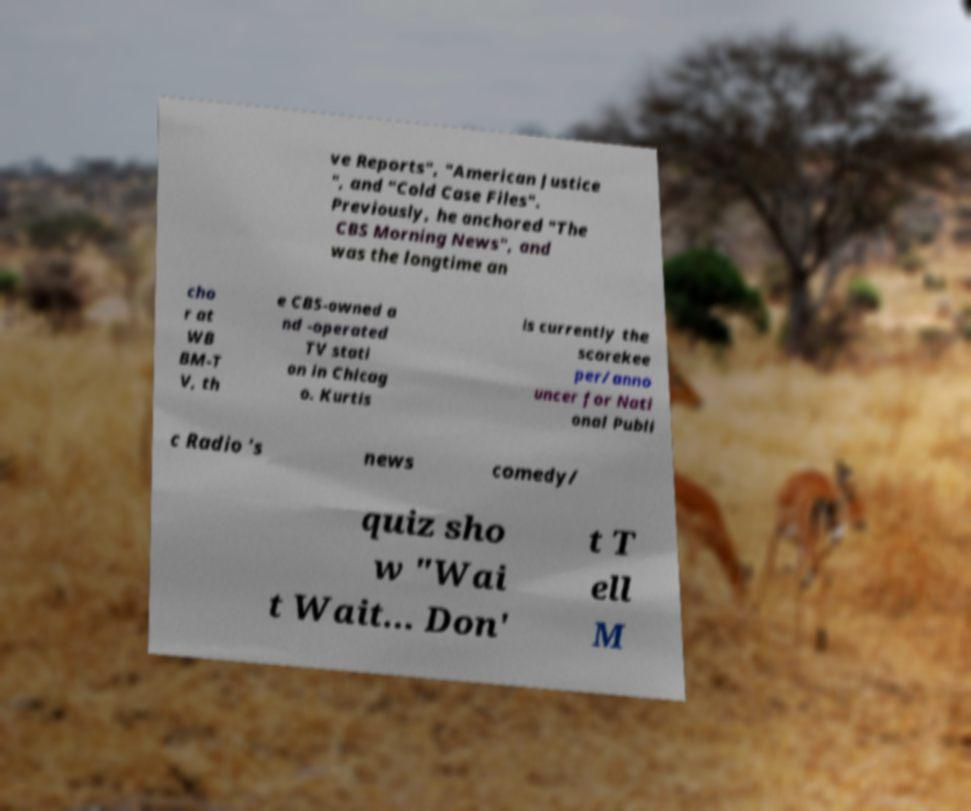Can you read and provide the text displayed in the image?This photo seems to have some interesting text. Can you extract and type it out for me? ve Reports", "American Justice ", and "Cold Case Files". Previously, he anchored "The CBS Morning News", and was the longtime an cho r at WB BM-T V, th e CBS-owned a nd -operated TV stati on in Chicag o. Kurtis is currently the scorekee per/anno uncer for Nati onal Publi c Radio 's news comedy/ quiz sho w "Wai t Wait... Don' t T ell M 